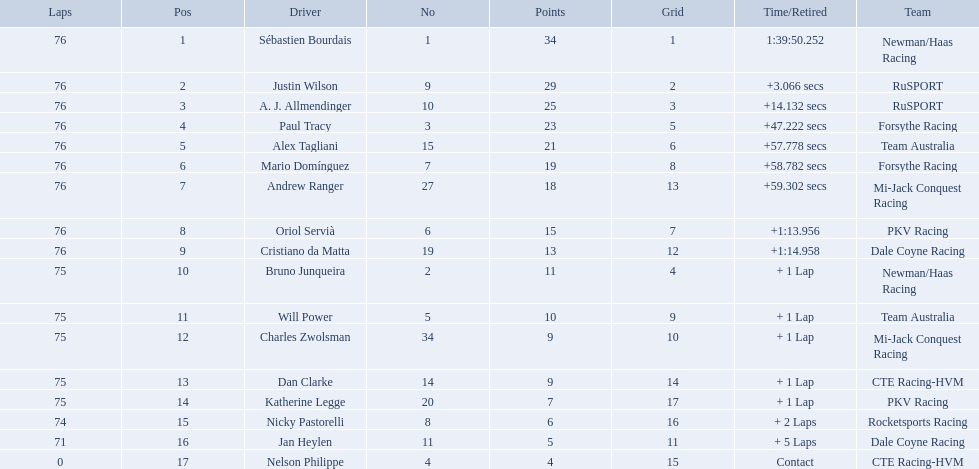Which drivers completed all 76 laps? Sébastien Bourdais, Justin Wilson, A. J. Allmendinger, Paul Tracy, Alex Tagliani, Mario Domínguez, Andrew Ranger, Oriol Servià, Cristiano da Matta. Of these drivers, which ones finished less than a minute behind first place? Paul Tracy, Alex Tagliani, Mario Domínguez, Andrew Ranger. Of these drivers, which ones finished with a time less than 50 seconds behind first place? Justin Wilson, A. J. Allmendinger, Paul Tracy. Of these three drivers, who finished last? Paul Tracy. 